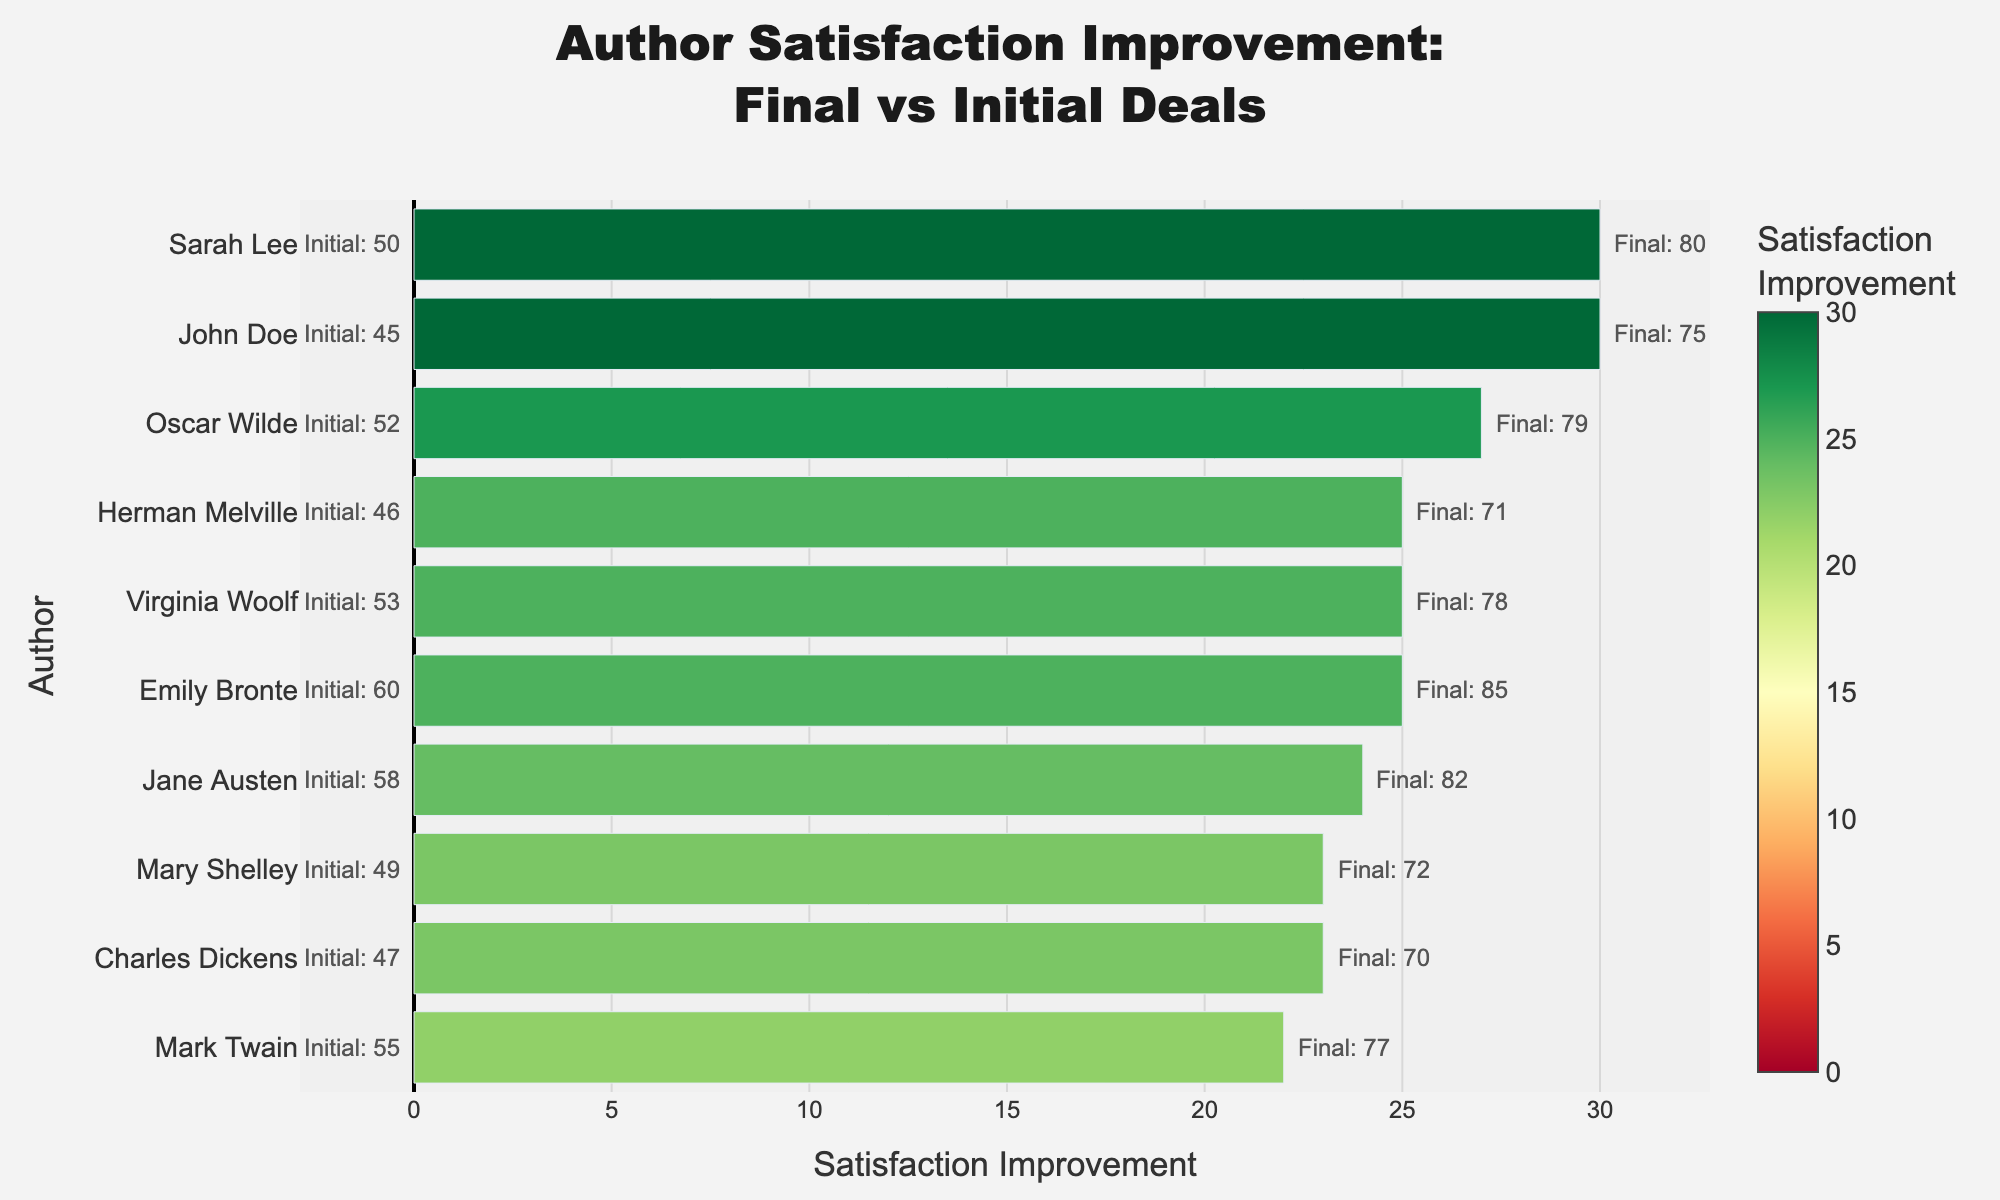What's the largest satisfaction improvement shown in the plot? The largest satisfaction improvement can be found by looking at the bar with the highest positive value. The corresponding value for that bar is the highest improvement.
Answer: 25 Which author experienced the least improvement in satisfaction? To find the author with the least improvement, locate the shortest bar. This represents the smallest difference between final and initial satisfaction.
Answer: Charles Dickens What is the average satisfaction improvement among the authors? Sum up all the satisfaction improvements, then divide by the number of authors. Improvements: 30, 27, 25, etc. Add them: 3 + 23 + 26 + 25 + 24 + 22 + 27 + 30 + 25 = 205. Divide by 10 (number of authors).
Answer: 20.5 Which authors have a satisfaction improvement greater than 20 points? Identify all bars whose lengths exceed 20 points. These authors have higher satisfaction improvements than the given threshold.
Answer: Sarah Lee, Mark Twain, Emily Bronte, Virginia Woolf, Oscar Wilde, Jane Austen Which author has an initial satisfaction closest to 50? Look for the annotation text that indicates initial satisfaction values around 50. Identify the author associated with this number.
Answer: Sarah Lee Do more authors have improvements above or below the average improvement? Calculate the average improvement (20.5). Count the number of authors with improvements greater than 20.5 and those with 20.5 or less. Compare the counts.
Answer: More authors have above average improvement Which author has the highest final satisfaction? Look for the annotation that indicates the highest final satisfaction value. Identify the corresponding author.
Answer: Emily Bronte How does John Doe's improvement compare to Jane Austen's? Examine the lengths of the bars corresponding to John Doe and Jane Austen. Calculate the difference between their satisfaction improvements.
Answer: John Doe's improvement is 5 points less than Jane Austen's 